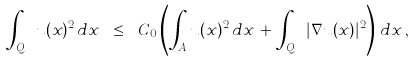Convert formula to latex. <formula><loc_0><loc_0><loc_500><loc_500>\int _ { Q _ { f } } u ( x ) ^ { 2 } \, d x \ \leq \ C _ { 0 } \left ( \int _ { A } u ( x ) ^ { 2 } \, d x \, + \, \int _ { Q _ { f } } | \nabla u ( x ) | ^ { 2 } \right ) \, d x \, ,</formula> 